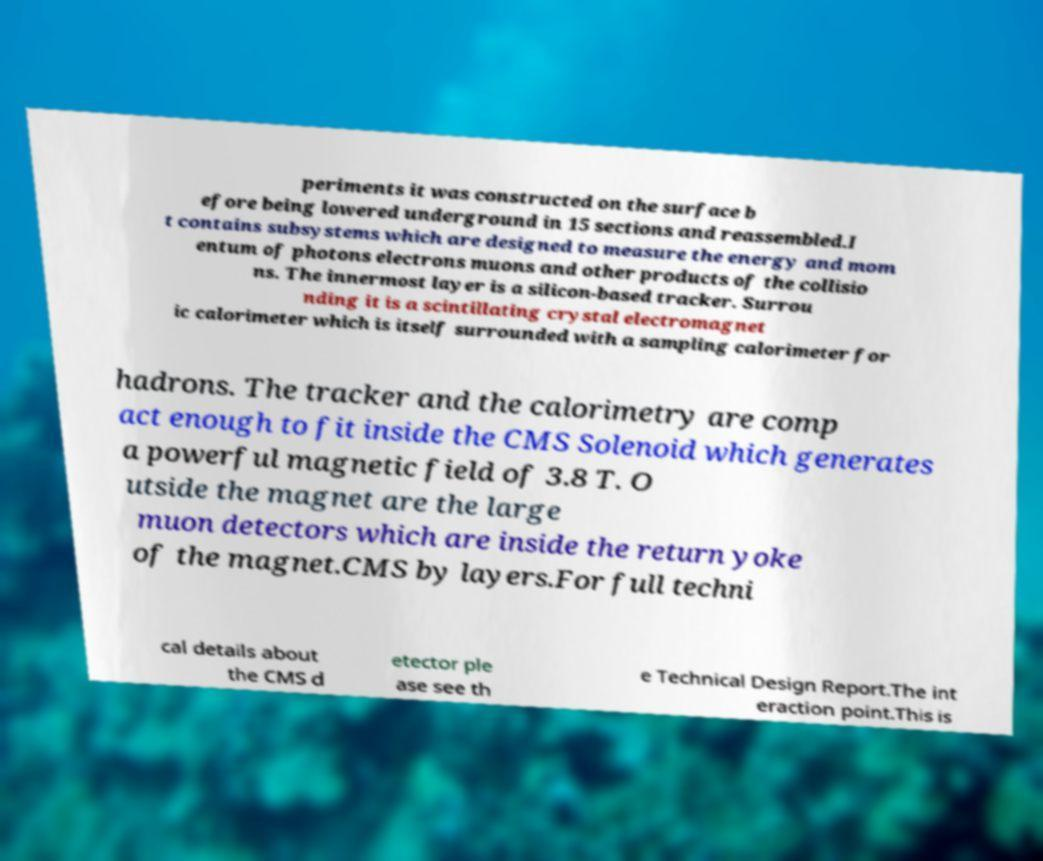For documentation purposes, I need the text within this image transcribed. Could you provide that? periments it was constructed on the surface b efore being lowered underground in 15 sections and reassembled.I t contains subsystems which are designed to measure the energy and mom entum of photons electrons muons and other products of the collisio ns. The innermost layer is a silicon-based tracker. Surrou nding it is a scintillating crystal electromagnet ic calorimeter which is itself surrounded with a sampling calorimeter for hadrons. The tracker and the calorimetry are comp act enough to fit inside the CMS Solenoid which generates a powerful magnetic field of 3.8 T. O utside the magnet are the large muon detectors which are inside the return yoke of the magnet.CMS by layers.For full techni cal details about the CMS d etector ple ase see th e Technical Design Report.The int eraction point.This is 